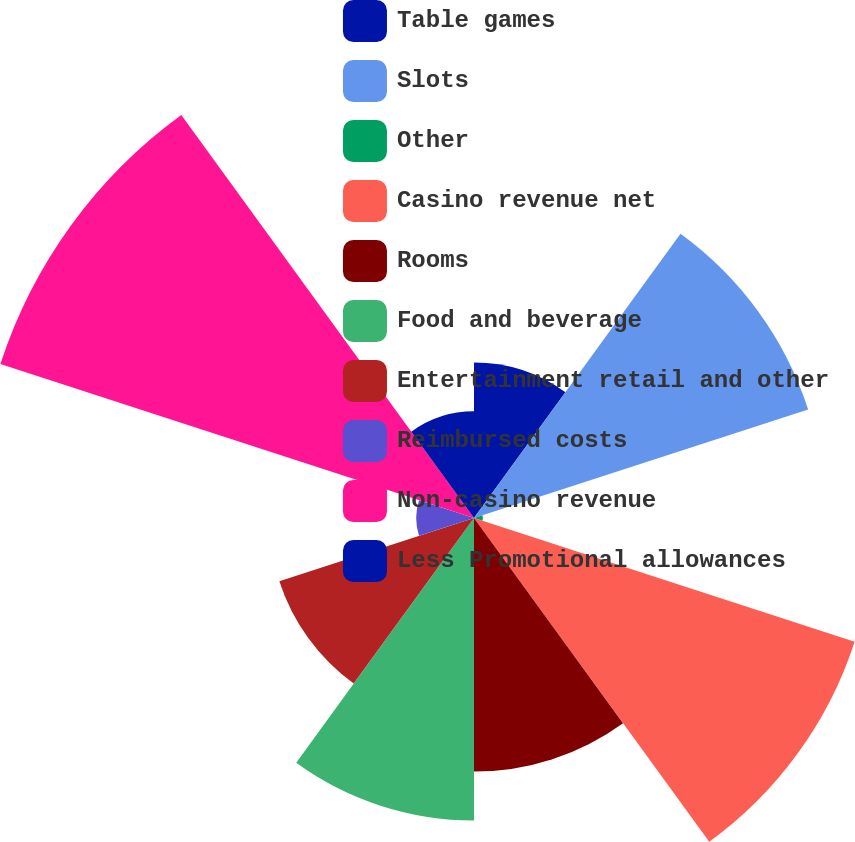Convert chart to OTSL. <chart><loc_0><loc_0><loc_500><loc_500><pie_chart><fcel>Table games<fcel>Slots<fcel>Other<fcel>Casino revenue net<fcel>Rooms<fcel>Food and beverage<fcel>Entertainment retail and other<fcel>Reimbursed costs<fcel>Non-casino revenue<fcel>Less Promotional allowances<nl><fcel>6.65%<fcel>15.02%<fcel>0.38%<fcel>17.11%<fcel>10.84%<fcel>12.93%<fcel>8.75%<fcel>2.47%<fcel>21.29%<fcel>4.56%<nl></chart> 